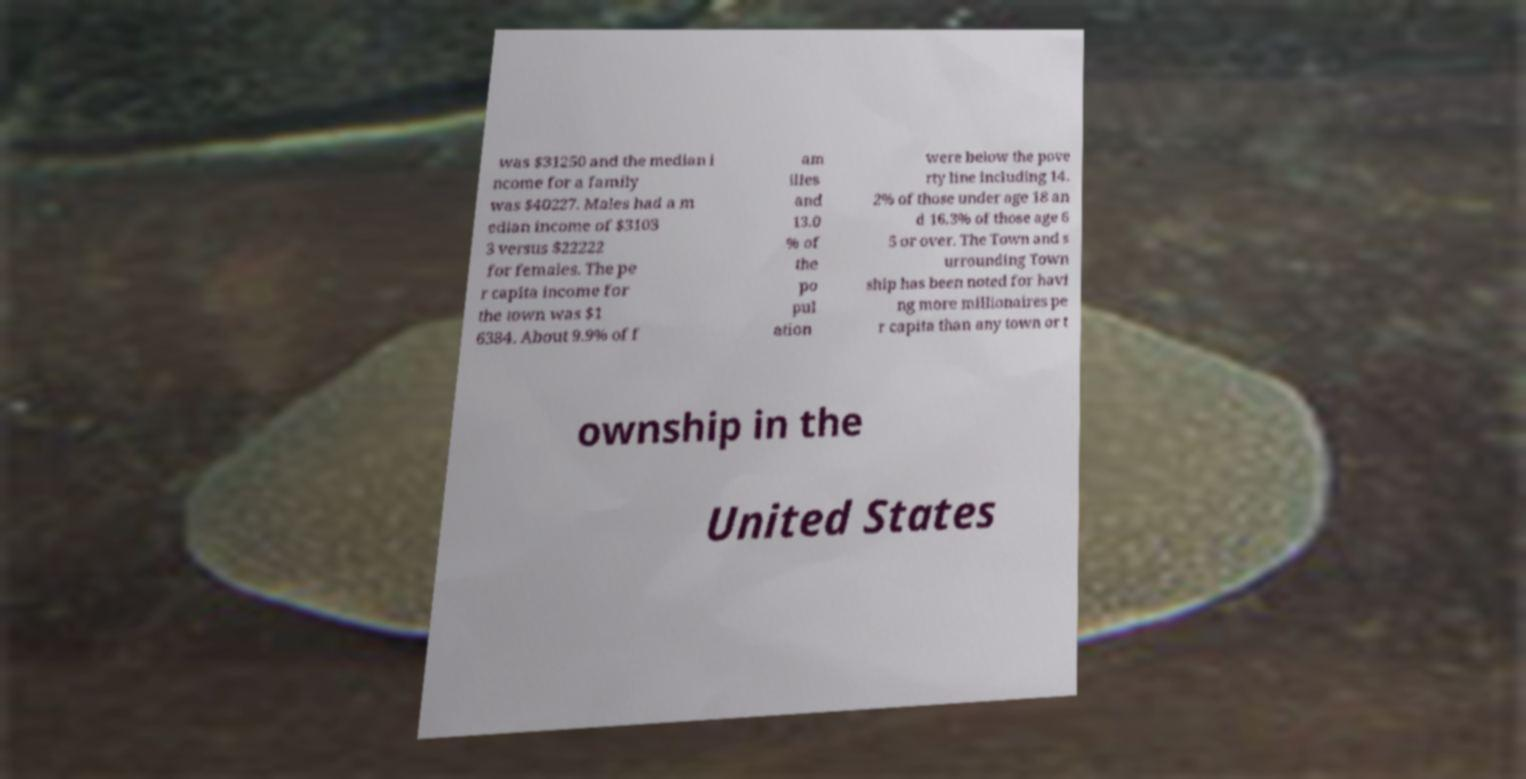I need the written content from this picture converted into text. Can you do that? was $31250 and the median i ncome for a family was $40227. Males had a m edian income of $3103 3 versus $22222 for females. The pe r capita income for the town was $1 6384. About 9.9% of f am ilies and 13.0 % of the po pul ation were below the pove rty line including 14. 2% of those under age 18 an d 16.3% of those age 6 5 or over. The Town and s urrounding Town ship has been noted for havi ng more millionaires pe r capita than any town or t ownship in the United States 